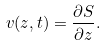<formula> <loc_0><loc_0><loc_500><loc_500>v ( z , t ) = \frac { \partial S } { \partial z } .</formula> 